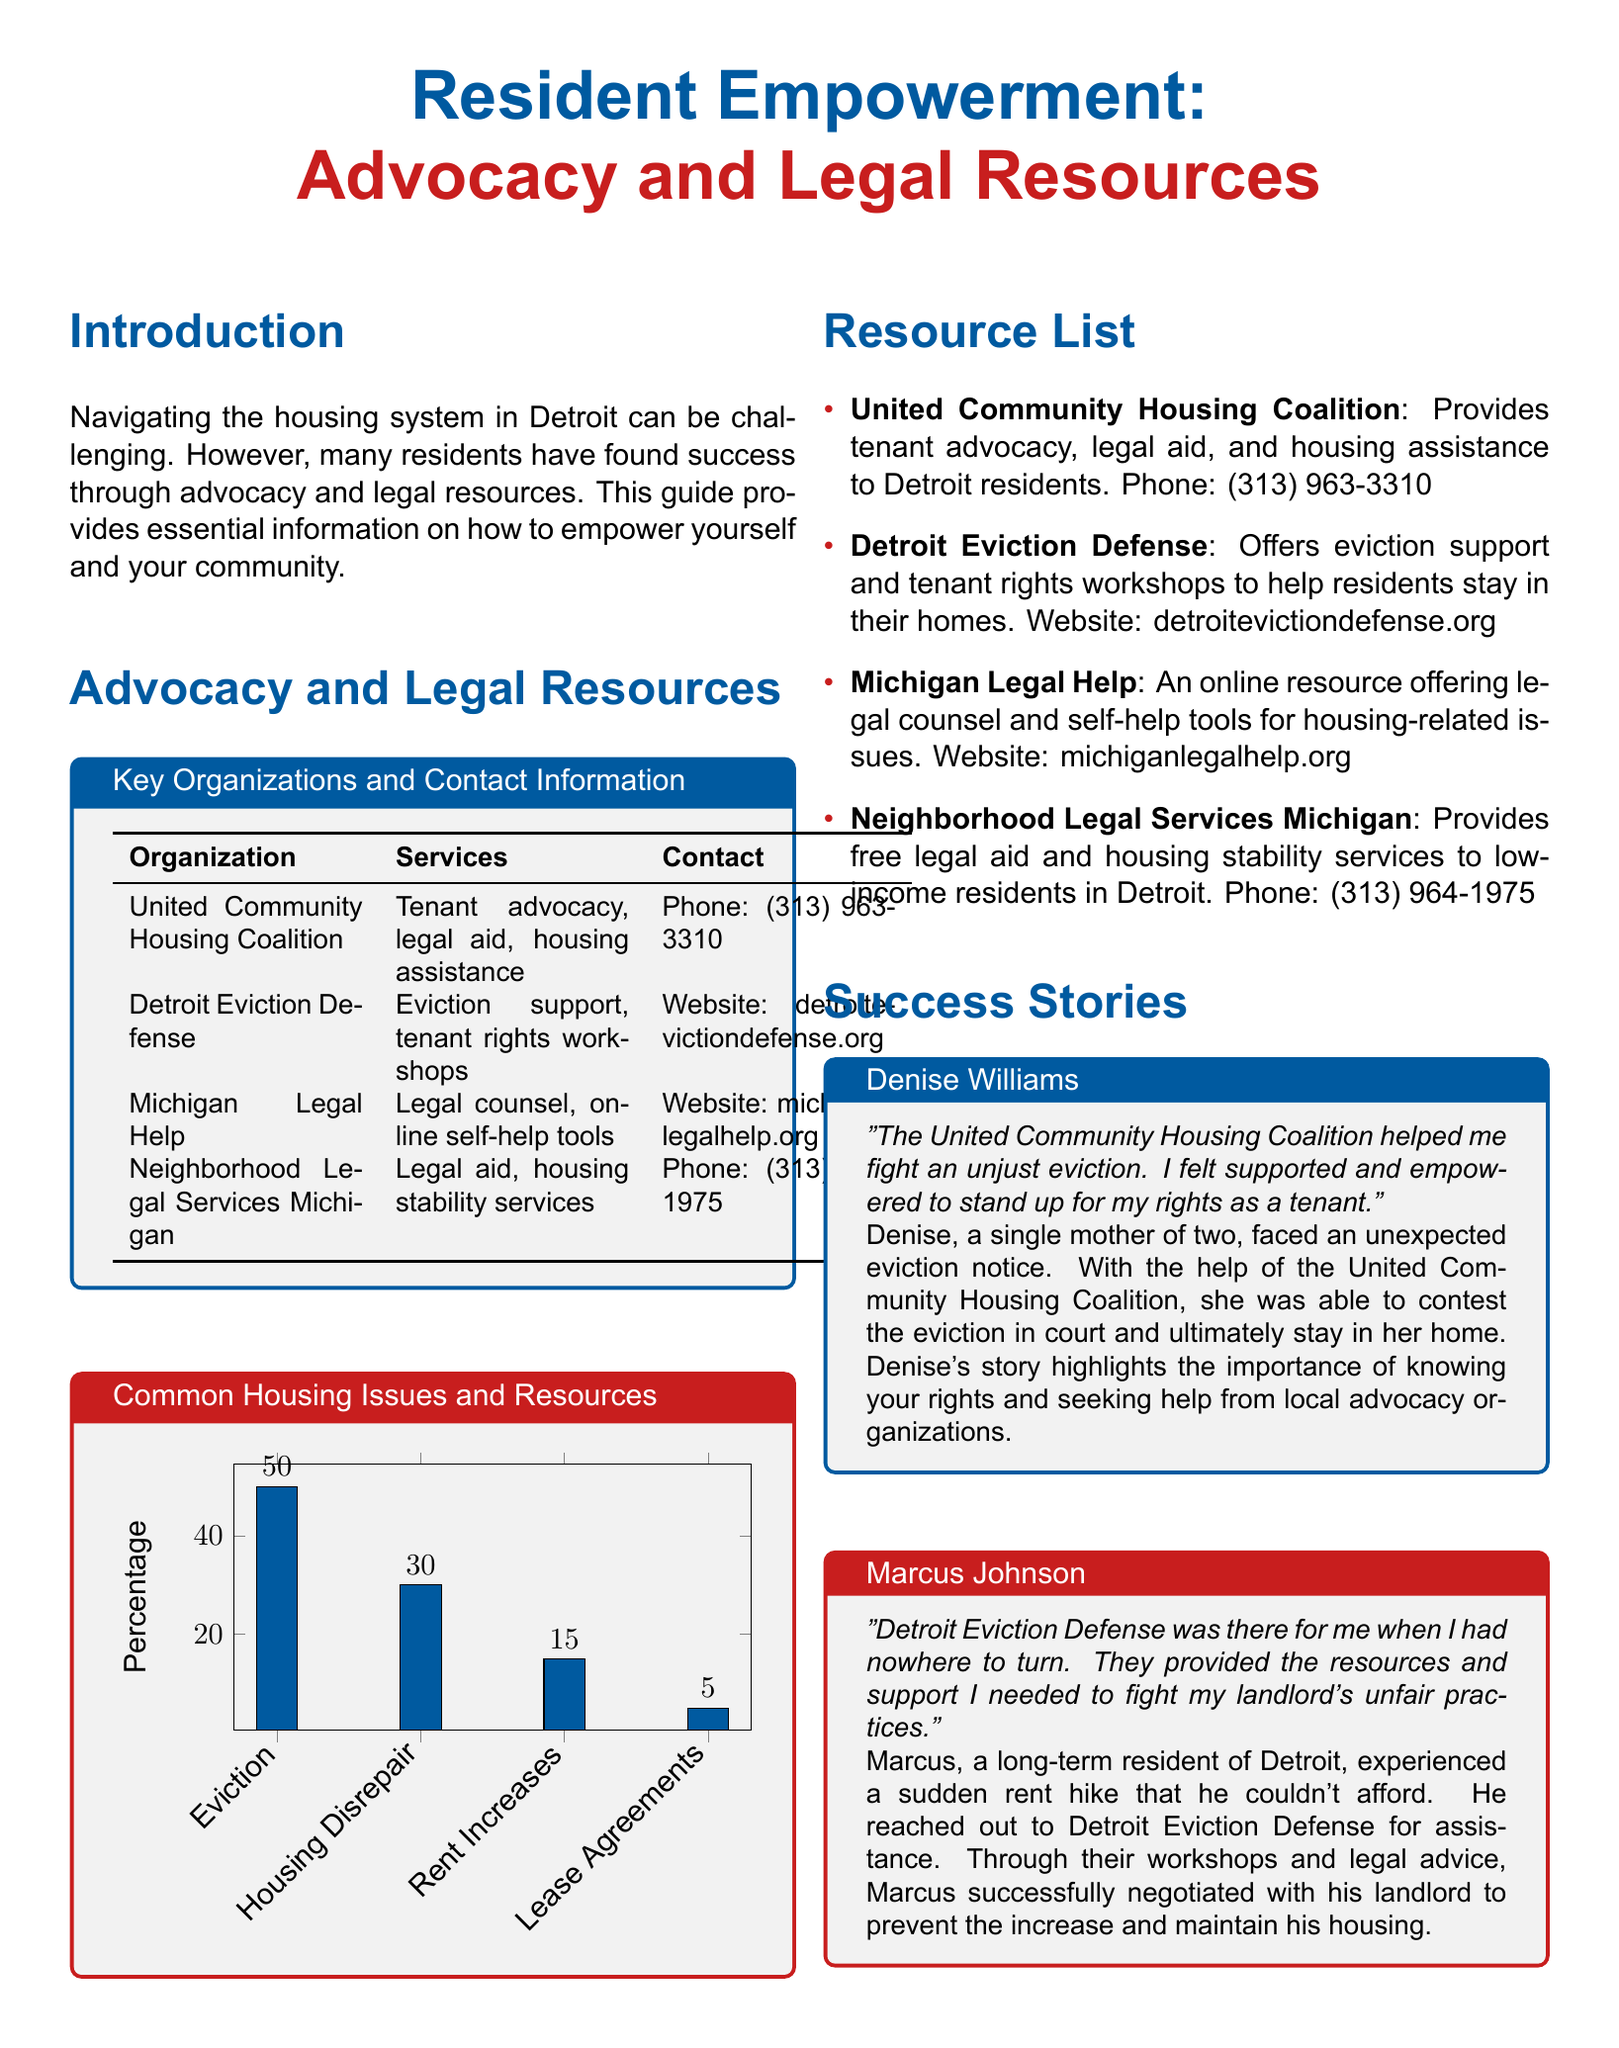What is the name of the housing advocacy organization? The organization mentioned in the document is the United Community Housing Coalition.
Answer: United Community Housing Coalition What service does Neighborhood Legal Services Michigan provide? The document states that Neighborhood Legal Services Michigan offers legal aid and housing stability services.
Answer: Legal aid, housing stability services What percentage of residents reported housing disrepair as an issue? According to the chart, 30% of residents reported housing disrepair.
Answer: 30 Who was supported by Detroit Eviction Defense? The document includes the story of Marcus Johnson, who was supported by Detroit Eviction Defense.
Answer: Marcus Johnson What is one resource provided by Michigan Legal Help? Michigan Legal Help offers online self-help tools as a resource.
Answer: Online self-help tools What was the outcome for Denise Williams? The document indicates that Denise Williams was able to contest the eviction and stay in her home.
Answer: Stay in her home What type of chart is included in the document? The document features a bar chart displaying common housing issues and their respective percentages.
Answer: Bar chart What is the contact method for Detroit Eviction Defense? The document states that Detroit Eviction Defense can be reached through their website.
Answer: Website: detroitevictiondefense.org How many organizations are listed in the resource section? The document lists four organizations in the resource section.
Answer: Four 